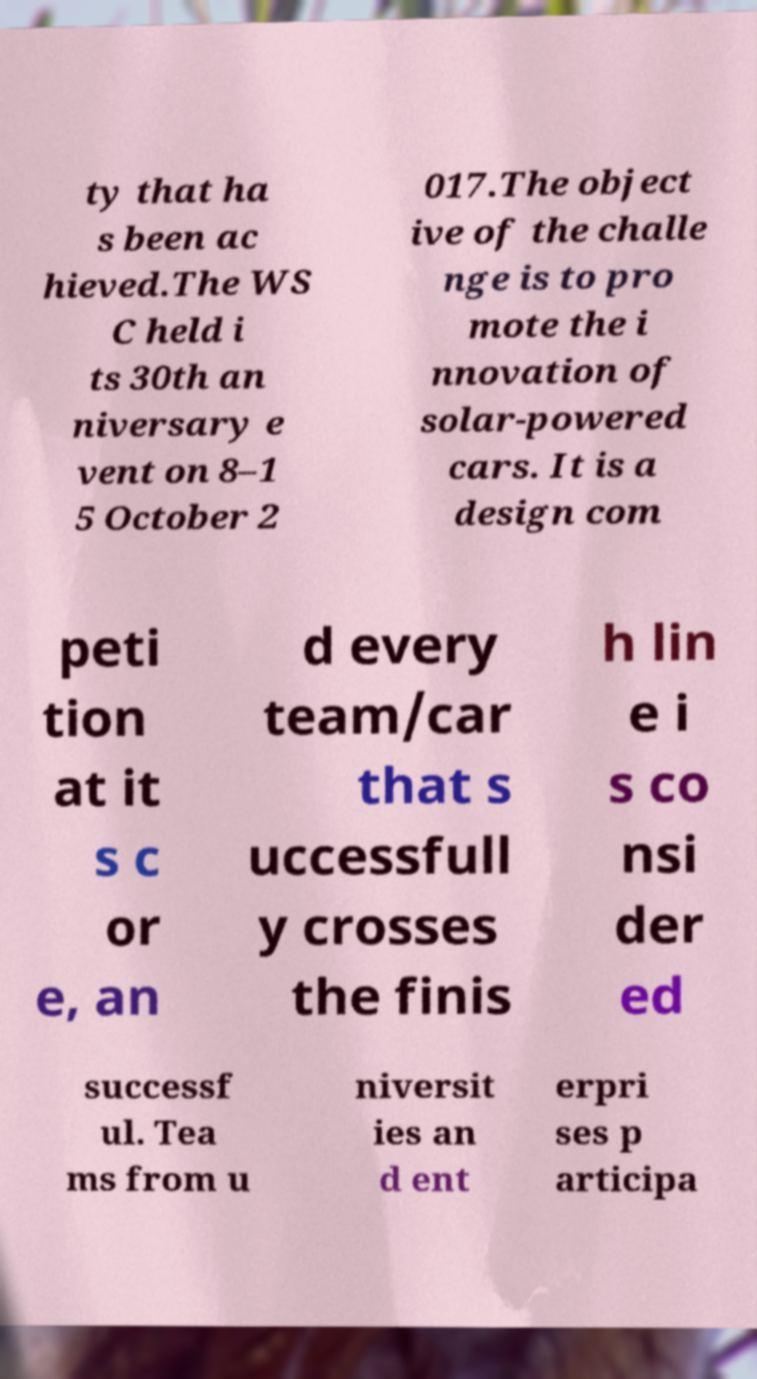For documentation purposes, I need the text within this image transcribed. Could you provide that? ty that ha s been ac hieved.The WS C held i ts 30th an niversary e vent on 8–1 5 October 2 017.The object ive of the challe nge is to pro mote the i nnovation of solar-powered cars. It is a design com peti tion at it s c or e, an d every team/car that s uccessfull y crosses the finis h lin e i s co nsi der ed successf ul. Tea ms from u niversit ies an d ent erpri ses p articipa 